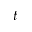Convert formula to latex. <formula><loc_0><loc_0><loc_500><loc_500>t</formula> 